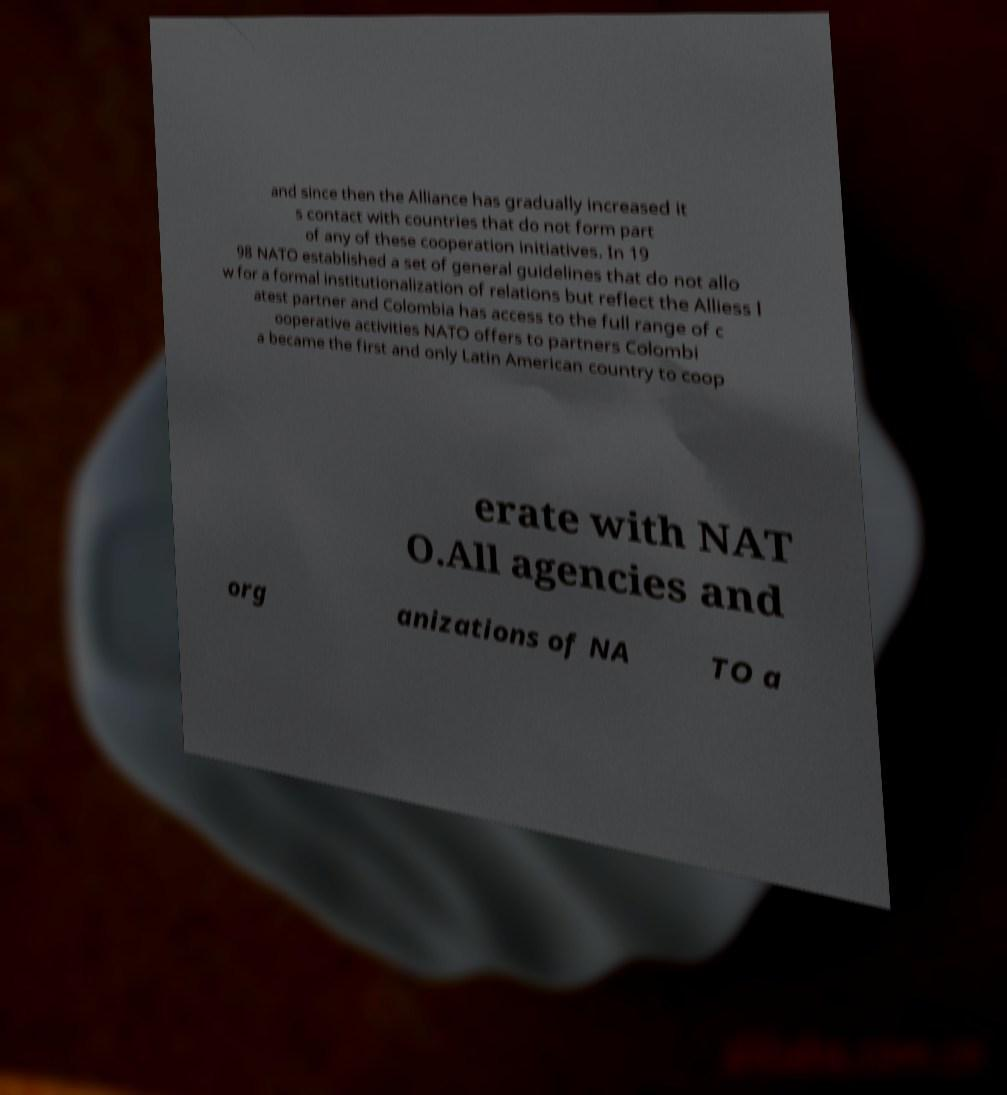Please read and relay the text visible in this image. What does it say? and since then the Alliance has gradually increased it s contact with countries that do not form part of any of these cooperation initiatives. In 19 98 NATO established a set of general guidelines that do not allo w for a formal institutionalization of relations but reflect the Alliess l atest partner and Colombia has access to the full range of c ooperative activities NATO offers to partners Colombi a became the first and only Latin American country to coop erate with NAT O.All agencies and org anizations of NA TO a 